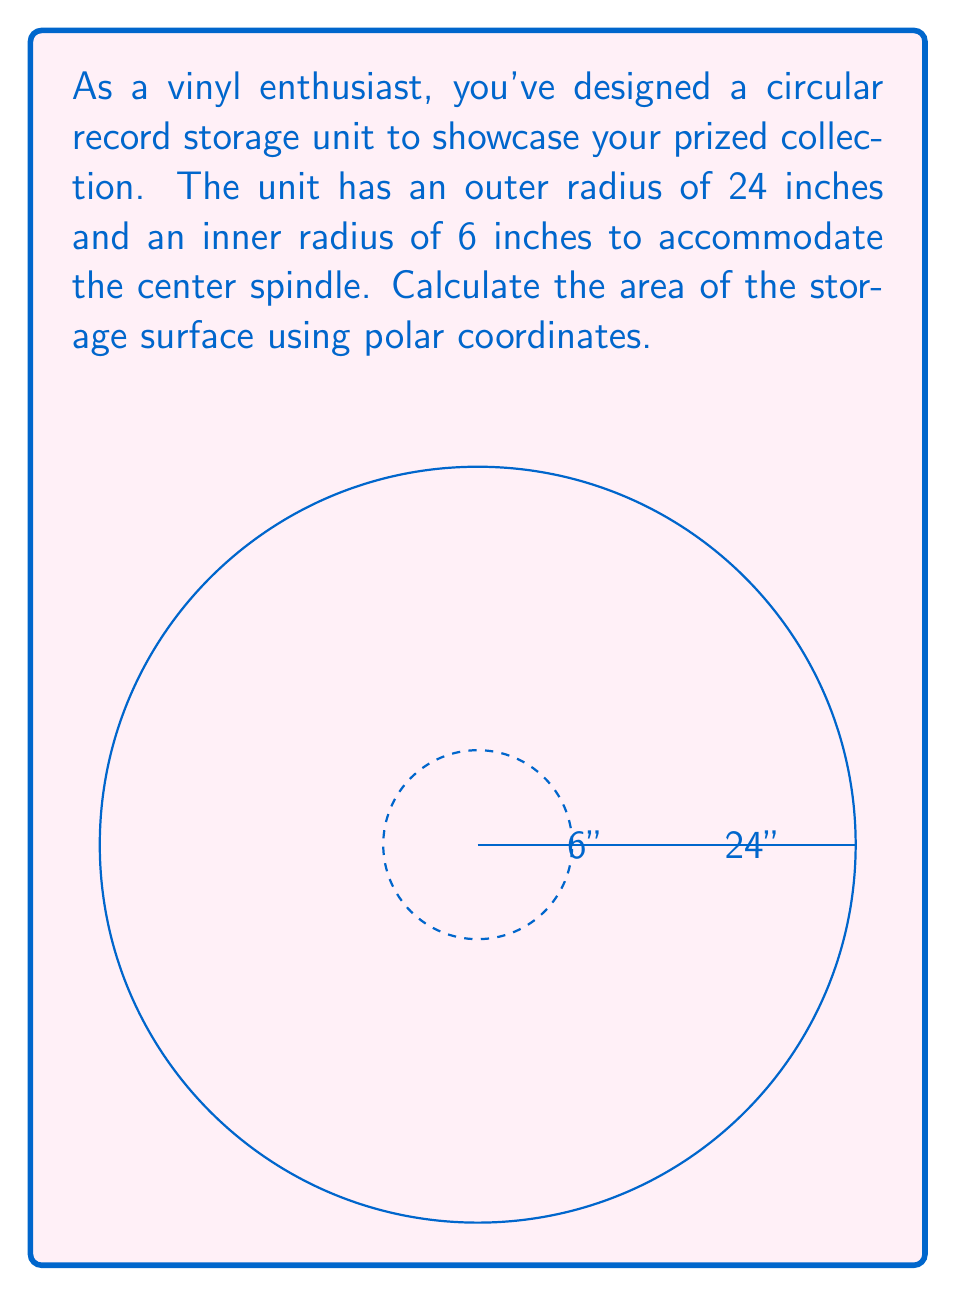What is the answer to this math problem? To calculate the area of the circular storage surface, we need to use the formula for the area in polar coordinates and subtract the inner circle from the outer circle:

1) The general formula for area in polar coordinates is:
   $$A = \int_a^b \frac{1}{2} r^2 d\theta$$

2) For a full circle, we integrate from 0 to 2π:
   $$A = \int_0^{2\pi} \frac{1}{2} r^2 d\theta$$

3) The area of the outer circle (r = 24):
   $$A_{\text{outer}} = \int_0^{2\pi} \frac{1}{2} (24)^2 d\theta = \frac{1}{2}(576)\int_0^{2\pi} d\theta = 288\pi$$

4) The area of the inner circle (r = 6):
   $$A_{\text{inner}} = \int_0^{2\pi} \frac{1}{2} (6)^2 d\theta = \frac{1}{2}(36)\int_0^{2\pi} d\theta = 18\pi$$

5) The area of the storage surface is the difference:
   $$A_{\text{storage}} = A_{\text{outer}} - A_{\text{inner}} = 288\pi - 18\pi = 270\pi$$

6) Therefore, the area of the storage surface is 270π square inches.
Answer: $270\pi$ square inches 